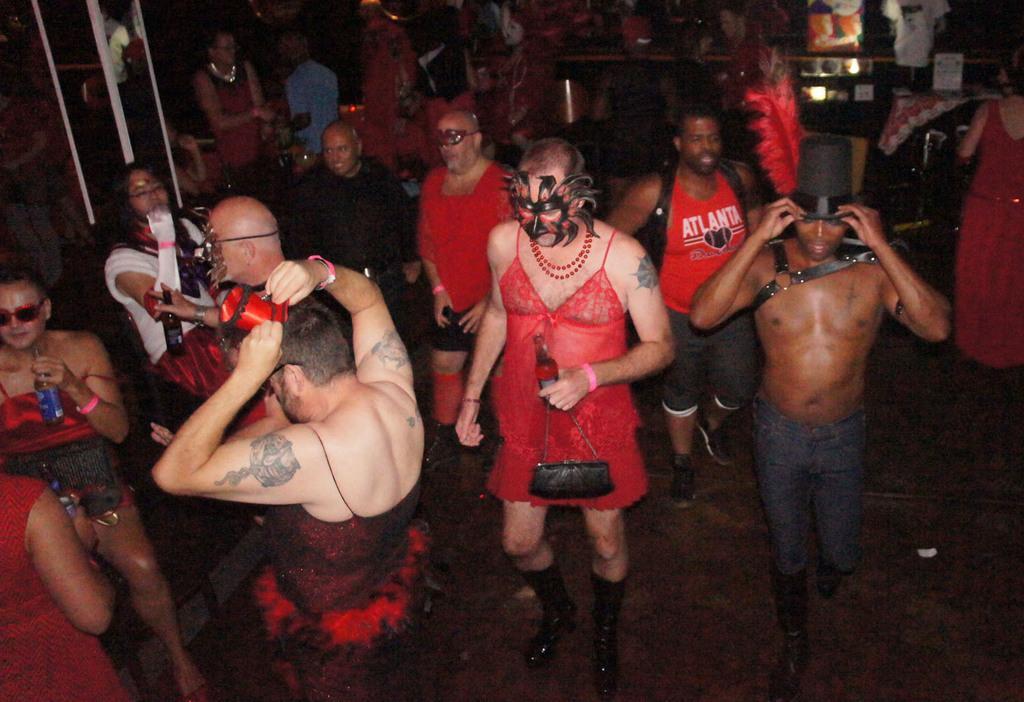Describe this image in one or two sentences. In this picture we can see some people are in one place, they are wearing masks to their faces. 